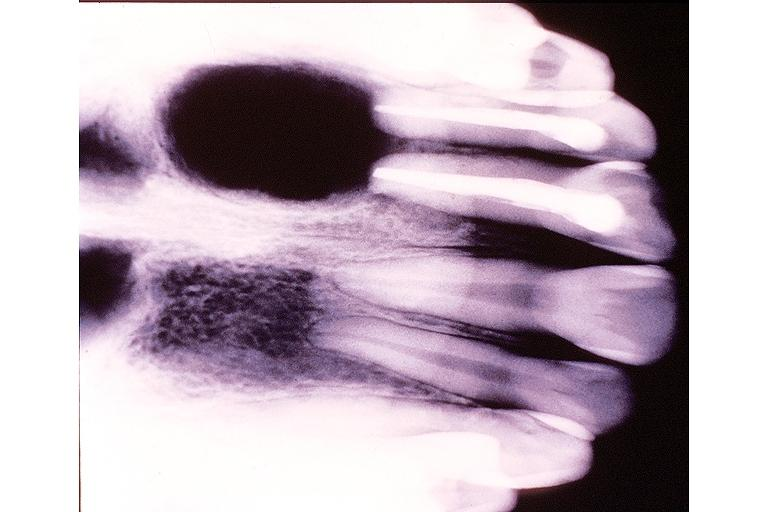does matting history of this case show radicular cyst?
Answer the question using a single word or phrase. No 